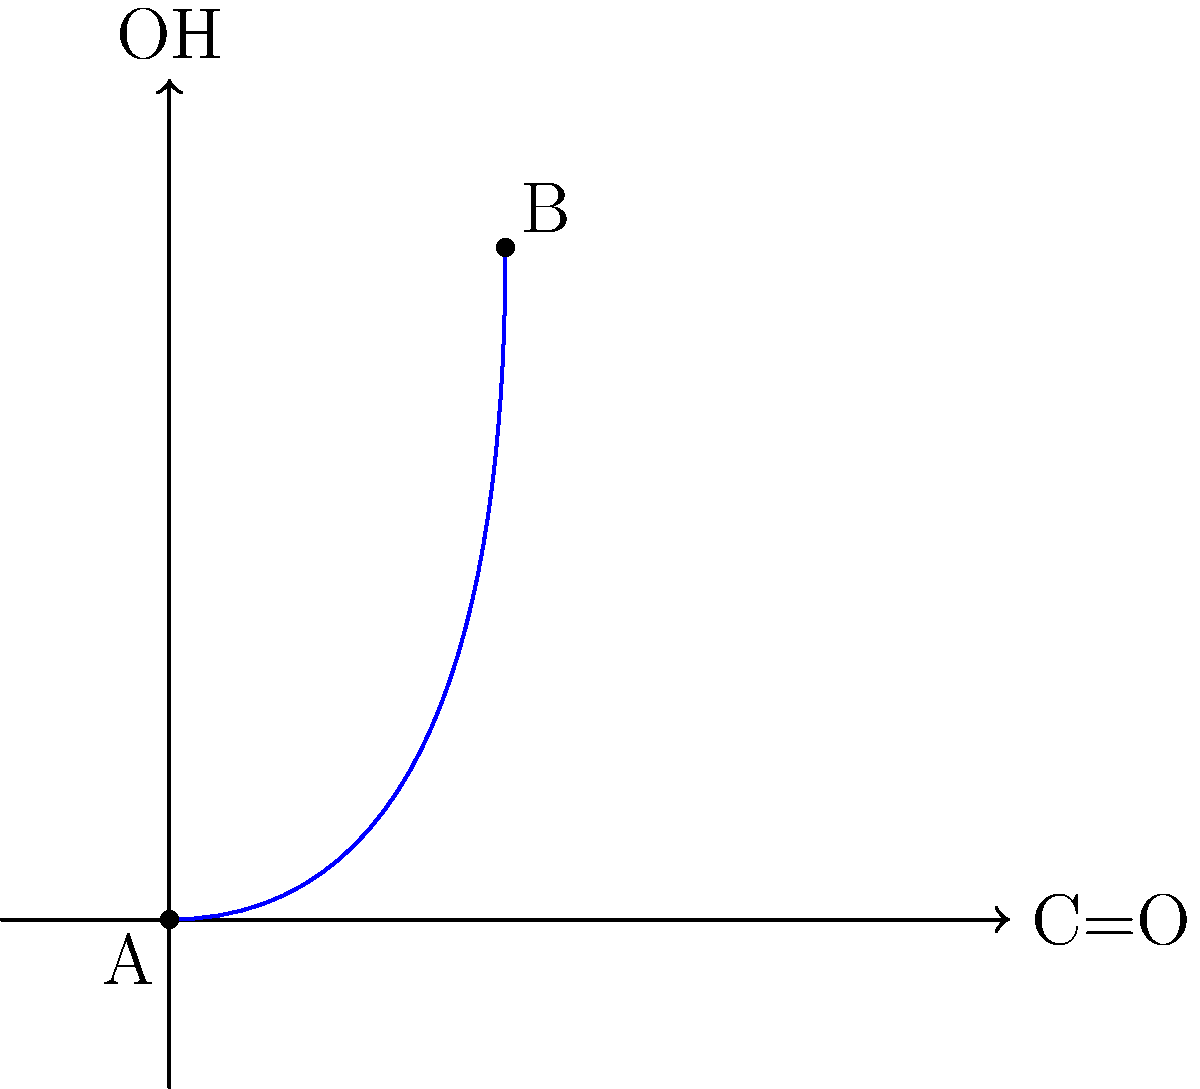The graph above represents the relationship between the concentration of carbonyl groups (C=O) and hydroxyl groups (OH) in a unique fragrant compound found in the rare Ambrosia plant. Point A represents the initial state of the compound, and point B represents its state after a chemical reaction. What type of reaction has likely occurred, and how would this affect the compound's fragrance profile? To determine the type of reaction and its effect on the fragrance profile, let's analyze the graph step-by-step:

1. Initial state (Point A):
   - Low concentration of both C=O and OH groups

2. Final state (Point B):
   - Increased concentration of both C=O and OH groups

3. Reaction type analysis:
   - The simultaneous increase in both C=O and OH groups suggests an oxidation reaction
   - Specifically, this is likely a partial oxidation of primary alcohols to aldehydes

4. Chemical process:
   - R-CH₂OH → R-CHO + H₂O
   - Primary alcohol is converted to an aldehyde, increasing C=O concentration
   - The reaction also produces water, increasing OH concentration

5. Effect on fragrance profile:
   - Aldehydes are known for their strong, often fruity or floral scents
   - The increase in aldehydes would likely intensify the fragrance
   - The presence of more OH groups could enhance the compound's solubility in water, potentially affecting its volatility and longevity

6. Overall impact:
   - The fragrance would become more intense and complex
   - The scent profile would shift towards aldehyde-dominant notes
   - The longevity of the fragrance may be altered due to changes in volatility

In conclusion, the reaction is likely a partial oxidation, resulting in a more intense and aldehyde-dominant fragrance profile with potentially altered longevity.
Answer: Partial oxidation; intensified aldehyde-dominant fragrance with altered longevity 